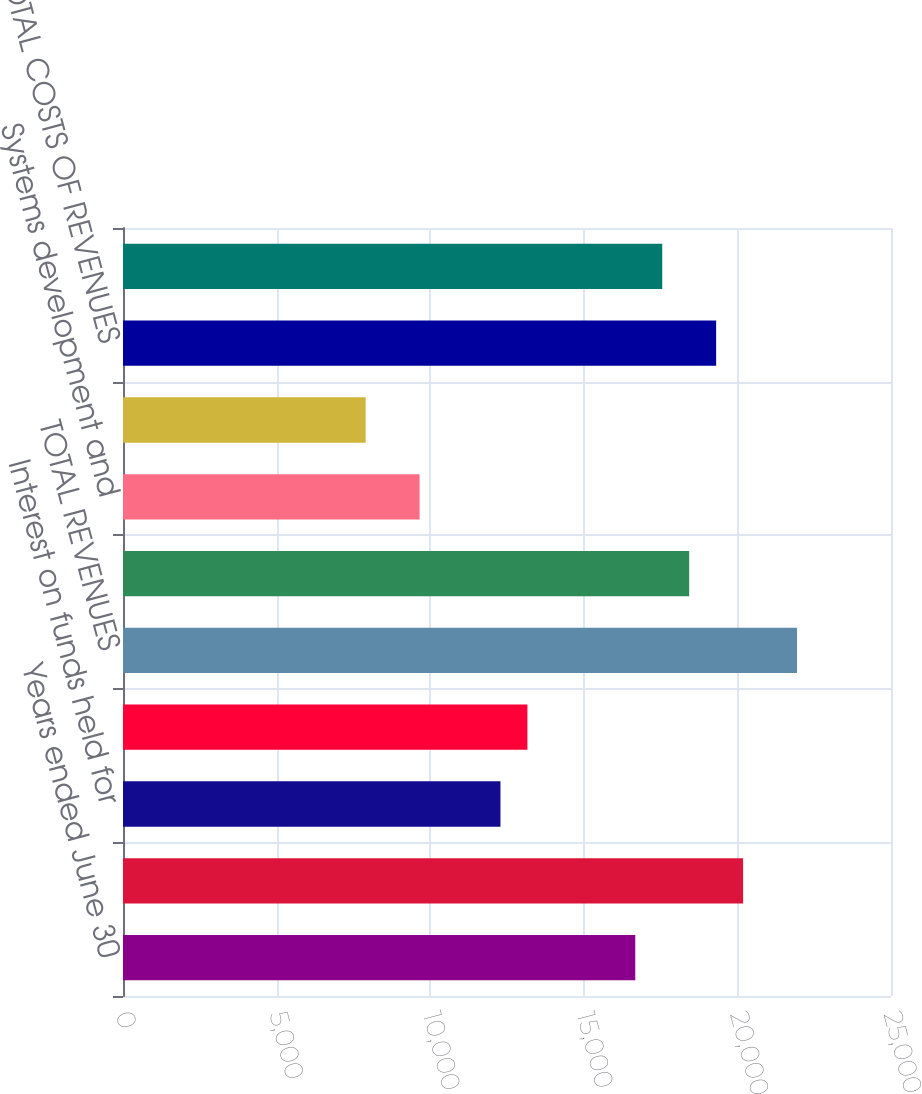<chart> <loc_0><loc_0><loc_500><loc_500><bar_chart><fcel>Years ended June 30<fcel>held for clients and PEO<fcel>Interest on funds held for<fcel>PEO revenues (A)<fcel>TOTAL REVENUES<fcel>Operating expenses<fcel>Systems development and<fcel>Depreciation and amortization<fcel>TOTAL COSTS OF REVENUES<fcel>Selling general and<nl><fcel>16675.3<fcel>20185.9<fcel>12287.1<fcel>13164.7<fcel>21941.1<fcel>18430.6<fcel>9654.18<fcel>7898.9<fcel>19308.2<fcel>17552.9<nl></chart> 